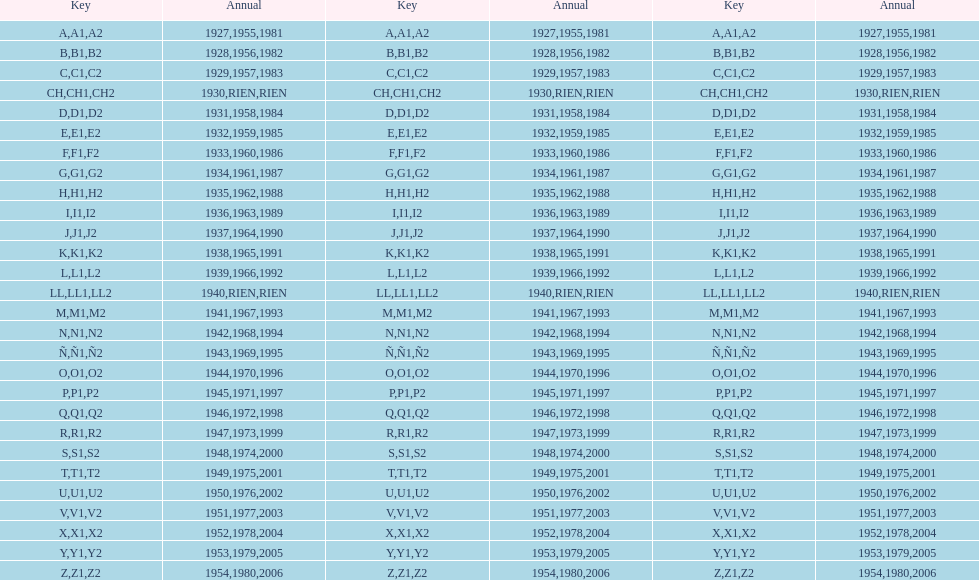Can you give me this table as a dict? {'header': ['Key', 'Annual', 'Key', 'Annual', 'Key', 'Annual'], 'rows': [['A', '1927', 'A1', '1955', 'A2', '1981'], ['B', '1928', 'B1', '1956', 'B2', '1982'], ['C', '1929', 'C1', '1957', 'C2', '1983'], ['CH', '1930', 'CH1', 'RIEN', 'CH2', 'RIEN'], ['D', '1931', 'D1', '1958', 'D2', '1984'], ['E', '1932', 'E1', '1959', 'E2', '1985'], ['F', '1933', 'F1', '1960', 'F2', '1986'], ['G', '1934', 'G1', '1961', 'G2', '1987'], ['H', '1935', 'H1', '1962', 'H2', '1988'], ['I', '1936', 'I1', '1963', 'I2', '1989'], ['J', '1937', 'J1', '1964', 'J2', '1990'], ['K', '1938', 'K1', '1965', 'K2', '1991'], ['L', '1939', 'L1', '1966', 'L2', '1992'], ['LL', '1940', 'LL1', 'RIEN', 'LL2', 'RIEN'], ['M', '1941', 'M1', '1967', 'M2', '1993'], ['N', '1942', 'N1', '1968', 'N2', '1994'], ['Ñ', '1943', 'Ñ1', '1969', 'Ñ2', '1995'], ['O', '1944', 'O1', '1970', 'O2', '1996'], ['P', '1945', 'P1', '1971', 'P2', '1997'], ['Q', '1946', 'Q1', '1972', 'Q2', '1998'], ['R', '1947', 'R1', '1973', 'R2', '1999'], ['S', '1948', 'S1', '1974', 'S2', '2000'], ['T', '1949', 'T1', '1975', 'T2', '2001'], ['U', '1950', 'U1', '1976', 'U2', '2002'], ['V', '1951', 'V1', '1977', 'V2', '2003'], ['X', '1952', 'X1', '1978', 'X2', '2004'], ['Y', '1953', 'Y1', '1979', 'Y2', '2005'], ['Z', '1954', 'Z1', '1980', 'Z2', '2006']]} What was the lowest year stamped? 1927. 